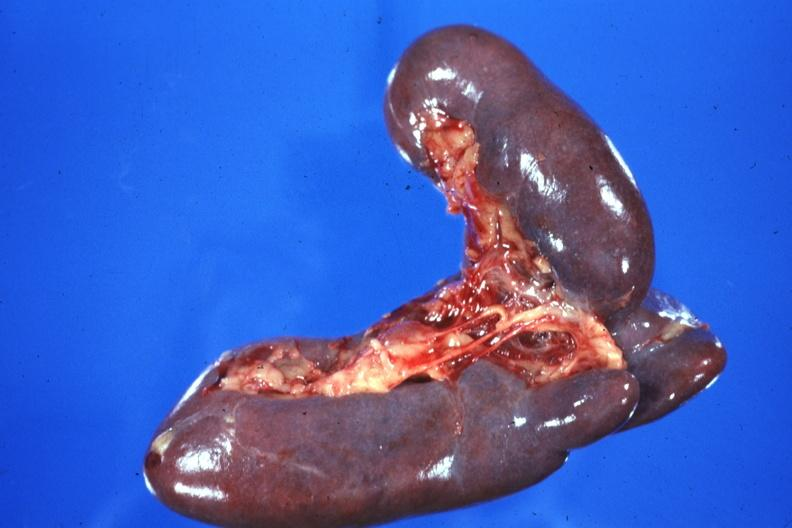what does this image show?
Answer the question using a single word or phrase. External view case of situs ambiguous partial left isomerism 